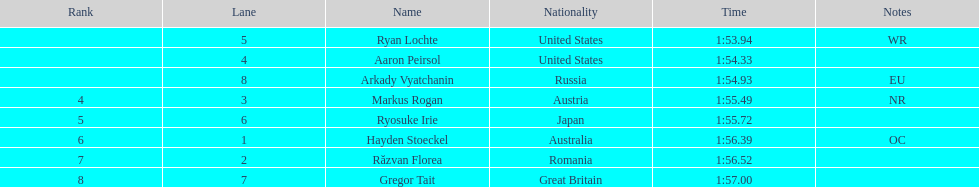Which country garnered the greatest amount of medals in the event? United States. 